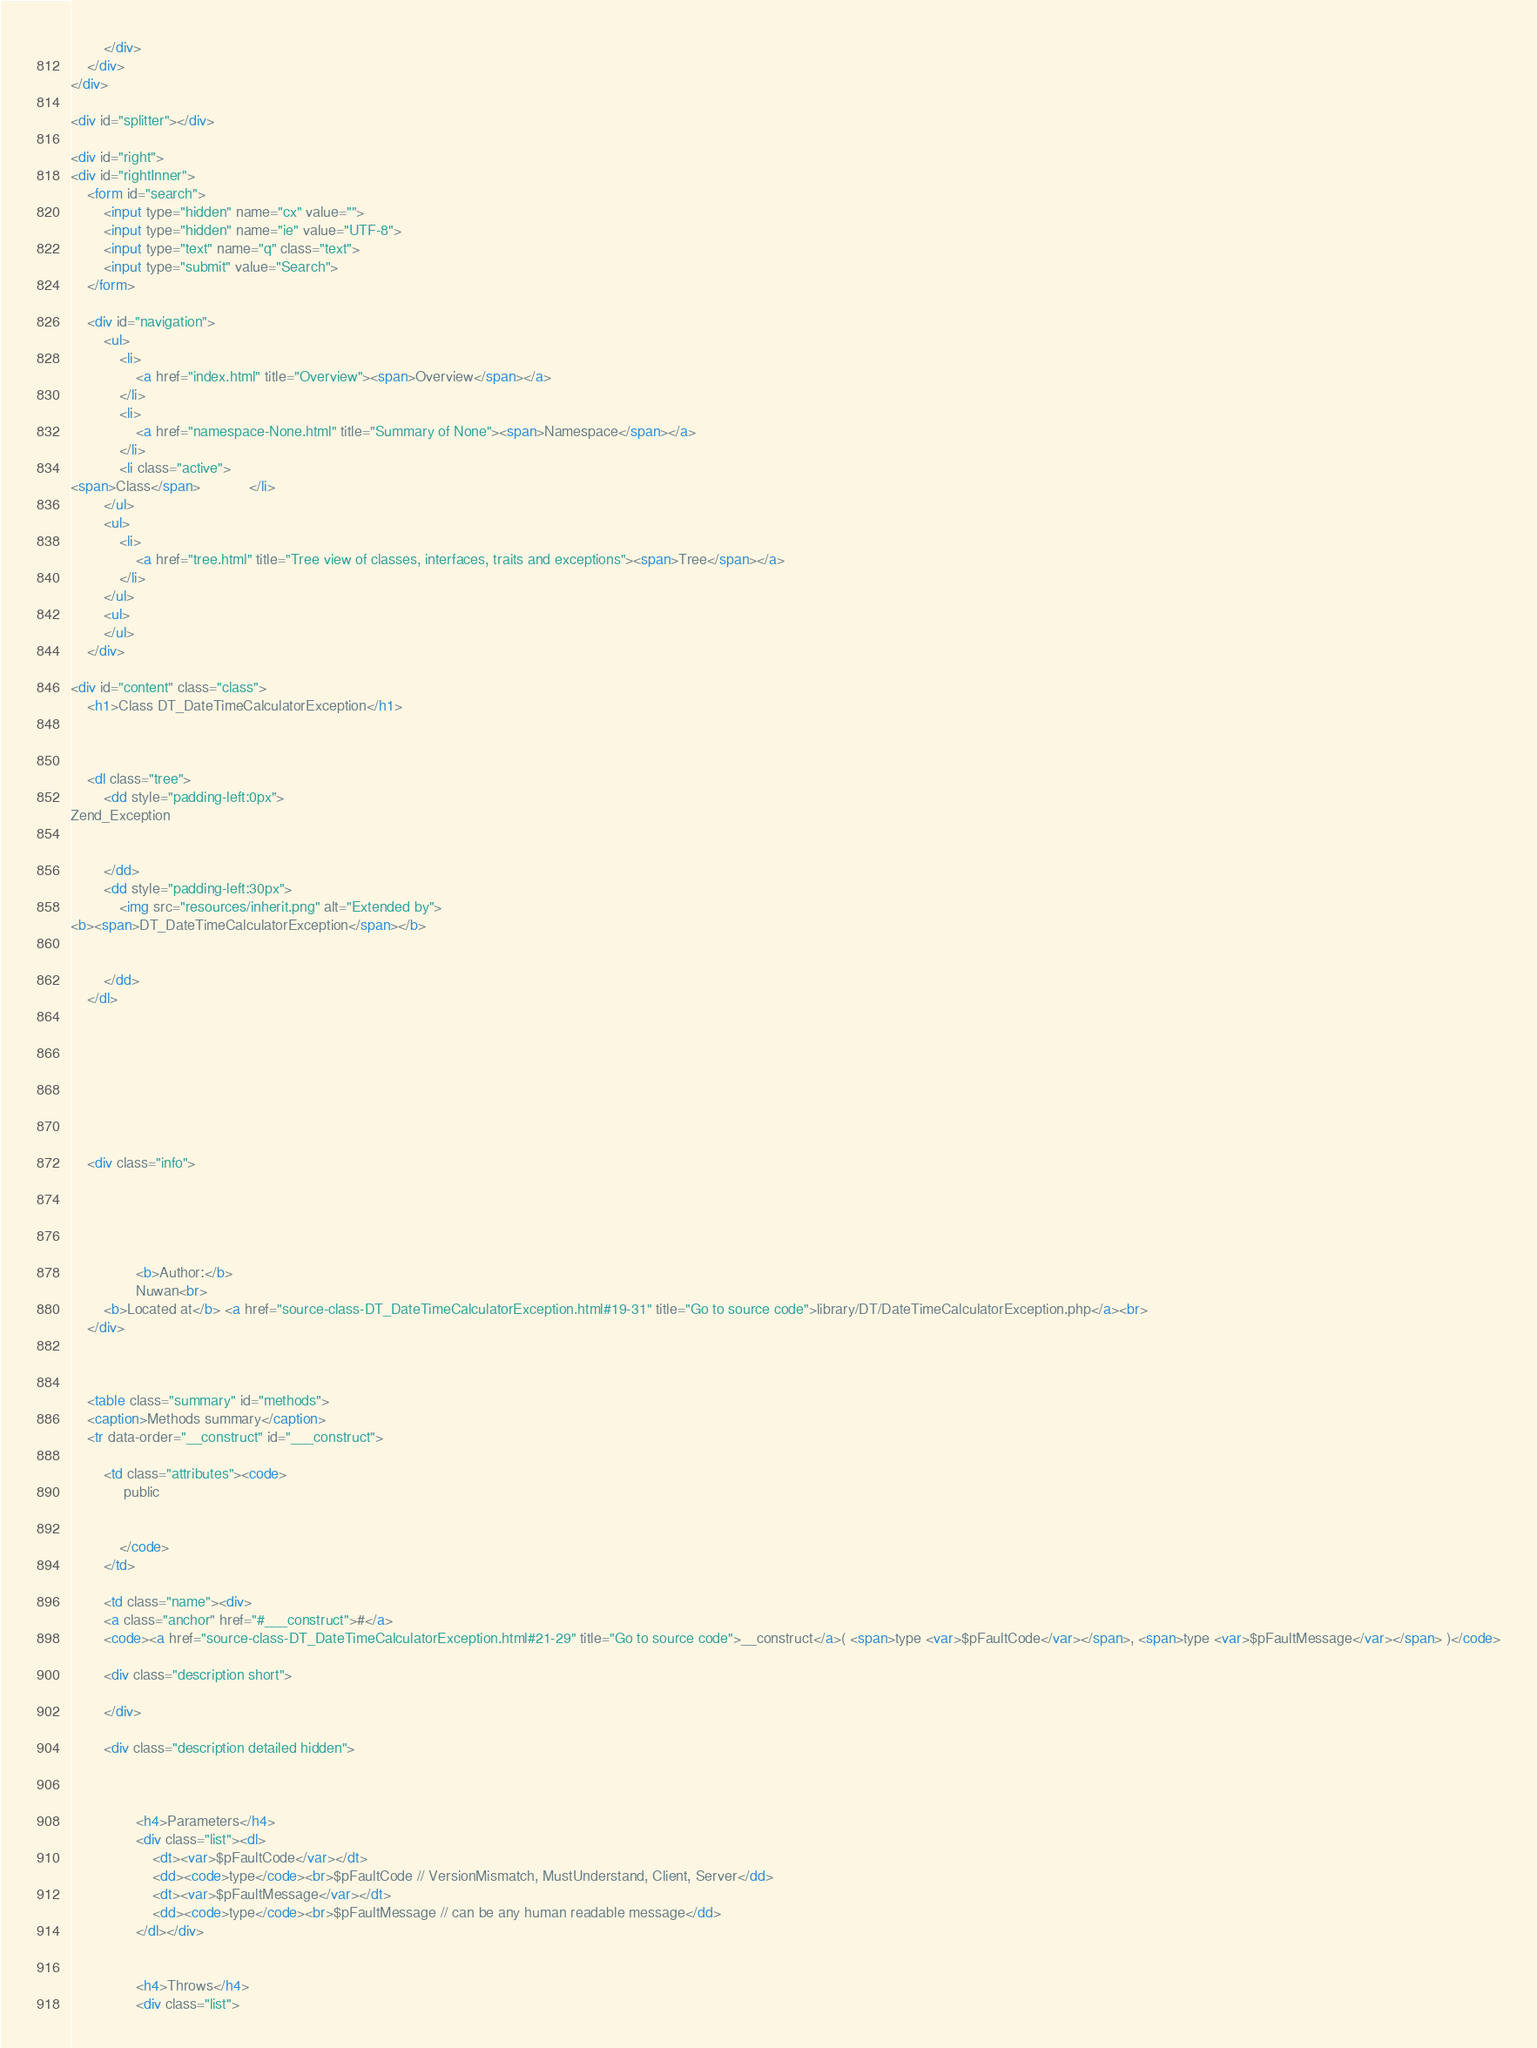<code> <loc_0><loc_0><loc_500><loc_500><_HTML_>

		</div>
	</div>
</div>

<div id="splitter"></div>

<div id="right">
<div id="rightInner">
	<form id="search">
		<input type="hidden" name="cx" value="">
		<input type="hidden" name="ie" value="UTF-8">
		<input type="text" name="q" class="text">
		<input type="submit" value="Search">
	</form>

	<div id="navigation">
		<ul>
			<li>
				<a href="index.html" title="Overview"><span>Overview</span></a>
			</li>
			<li>
				<a href="namespace-None.html" title="Summary of None"><span>Namespace</span></a>
			</li>
			<li class="active">
<span>Class</span>			</li>
		</ul>
		<ul>
			<li>
				<a href="tree.html" title="Tree view of classes, interfaces, traits and exceptions"><span>Tree</span></a>
			</li>
		</ul>
		<ul>
		</ul>
	</div>

<div id="content" class="class">
	<h1>Class DT_DateTimeCalculatorException</h1>



	<dl class="tree">
		<dd style="padding-left:0px">
Zend_Exception
			
			
		</dd>
		<dd style="padding-left:30px">
			<img src="resources/inherit.png" alt="Extended by">
<b><span>DT_DateTimeCalculatorException</span></b>			
			
			
		</dd>
	</dl>








	<div class="info">
		
		
		
		

				<b>Author:</b>
				Nuwan<br>
		<b>Located at</b> <a href="source-class-DT_DateTimeCalculatorException.html#19-31" title="Go to source code">library/DT/DateTimeCalculatorException.php</a><br>
	</div>



	<table class="summary" id="methods">
	<caption>Methods summary</caption>
	<tr data-order="__construct" id="___construct">

		<td class="attributes"><code>
			 public 
			
			
			</code>
		</td>

		<td class="name"><div>
		<a class="anchor" href="#___construct">#</a>
		<code><a href="source-class-DT_DateTimeCalculatorException.html#21-29" title="Go to source code">__construct</a>( <span>type <var>$pFaultCode</var></span>, <span>type <var>$pFaultMessage</var></span> )</code>

		<div class="description short">
			
		</div>

		<div class="description detailed hidden">
			


				<h4>Parameters</h4>
				<div class="list"><dl>
					<dt><var>$pFaultCode</var></dt>
					<dd><code>type</code><br>$pFaultCode // VersionMismatch, MustUnderstand, Client, Server</dd>
					<dt><var>$pFaultMessage</var></dt>
					<dd><code>type</code><br>$pFaultMessage // can be any human readable message</dd>
				</dl></div>


				<h4>Throws</h4>
				<div class="list"></code> 